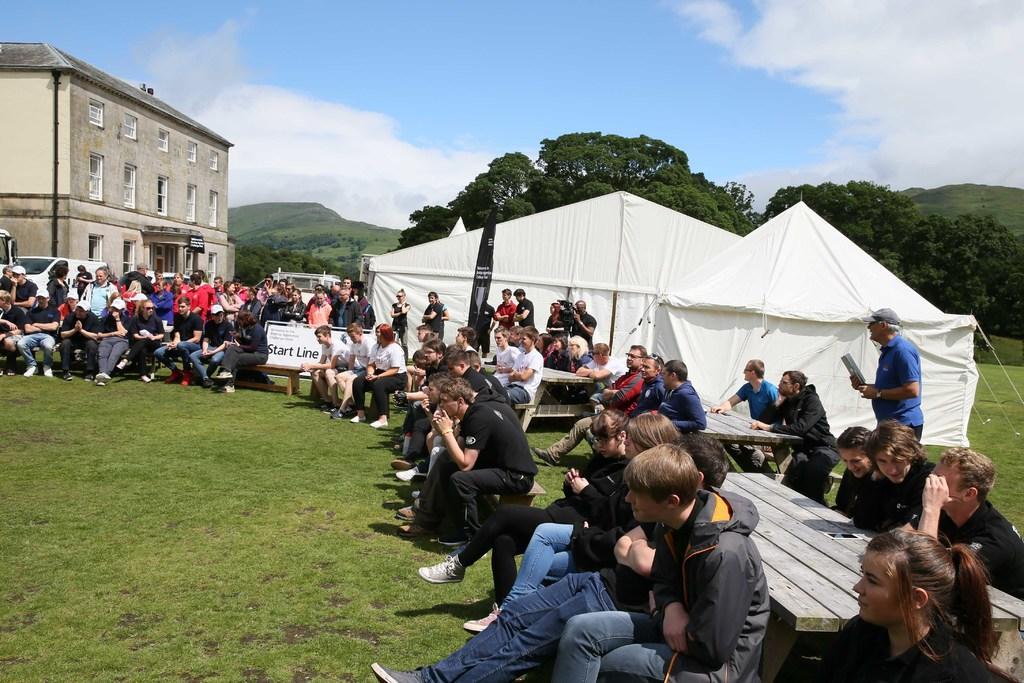In one or two sentences, can you explain what this image depicts? This image consists of many people sitting in the garden. At the bottom, there is green grass. On the right, there are tents. On the left, there is a building. In the background, there are trees. And there are clouds in the sky. 